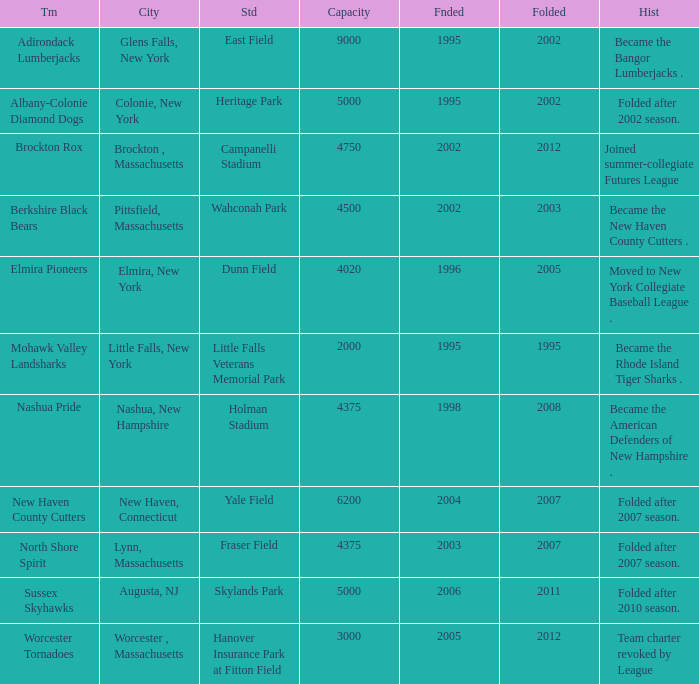What is the maximum founded year of the Worcester Tornadoes? 2005.0. 